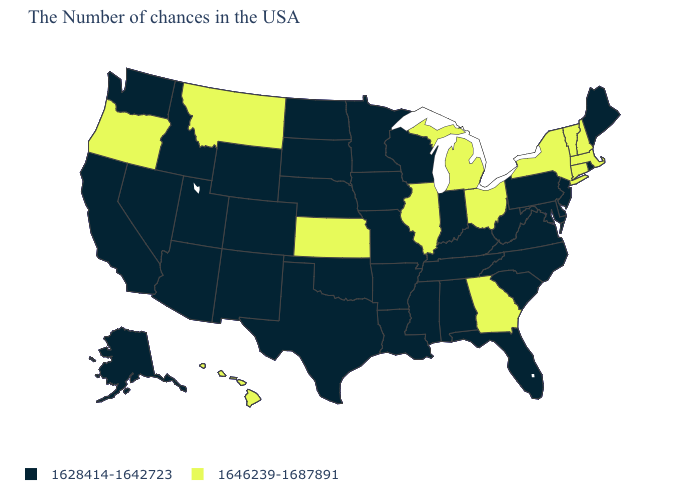Name the states that have a value in the range 1646239-1687891?
Quick response, please. Massachusetts, New Hampshire, Vermont, Connecticut, New York, Ohio, Georgia, Michigan, Illinois, Kansas, Montana, Oregon, Hawaii. How many symbols are there in the legend?
Concise answer only. 2. Which states hav the highest value in the MidWest?
Quick response, please. Ohio, Michigan, Illinois, Kansas. What is the value of Alaska?
Concise answer only. 1628414-1642723. Does the map have missing data?
Quick response, please. No. Name the states that have a value in the range 1646239-1687891?
Be succinct. Massachusetts, New Hampshire, Vermont, Connecticut, New York, Ohio, Georgia, Michigan, Illinois, Kansas, Montana, Oregon, Hawaii. What is the value of Maryland?
Keep it brief. 1628414-1642723. Name the states that have a value in the range 1628414-1642723?
Give a very brief answer. Maine, Rhode Island, New Jersey, Delaware, Maryland, Pennsylvania, Virginia, North Carolina, South Carolina, West Virginia, Florida, Kentucky, Indiana, Alabama, Tennessee, Wisconsin, Mississippi, Louisiana, Missouri, Arkansas, Minnesota, Iowa, Nebraska, Oklahoma, Texas, South Dakota, North Dakota, Wyoming, Colorado, New Mexico, Utah, Arizona, Idaho, Nevada, California, Washington, Alaska. Which states have the highest value in the USA?
Answer briefly. Massachusetts, New Hampshire, Vermont, Connecticut, New York, Ohio, Georgia, Michigan, Illinois, Kansas, Montana, Oregon, Hawaii. What is the value of California?
Answer briefly. 1628414-1642723. What is the value of Utah?
Concise answer only. 1628414-1642723. Name the states that have a value in the range 1646239-1687891?
Write a very short answer. Massachusetts, New Hampshire, Vermont, Connecticut, New York, Ohio, Georgia, Michigan, Illinois, Kansas, Montana, Oregon, Hawaii. What is the lowest value in the USA?
Be succinct. 1628414-1642723. What is the lowest value in the South?
Write a very short answer. 1628414-1642723. Does Illinois have the lowest value in the USA?
Answer briefly. No. 